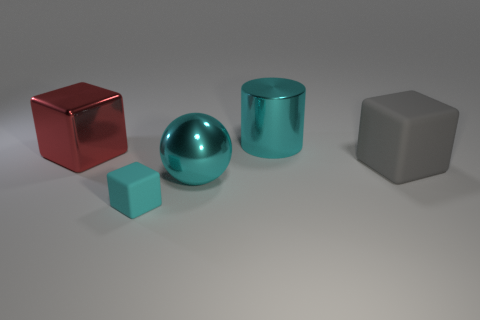There is a sphere that is the same color as the small cube; what size is it?
Provide a succinct answer. Large. There is a tiny rubber thing; does it have the same color as the big metallic object that is in front of the gray cube?
Offer a terse response. Yes. What is the color of the object that is to the right of the red thing and left of the ball?
Provide a succinct answer. Cyan. What number of other things are there of the same shape as the big matte object?
Make the answer very short. 2. Is the color of the matte object left of the cyan metallic cylinder the same as the big metallic thing in front of the large gray cube?
Offer a very short reply. Yes. There is a cyan shiny object right of the big cyan metal sphere; is it the same size as the cyan block to the right of the red object?
Keep it short and to the point. No. What material is the cyan object that is behind the cyan metal object on the left side of the large cyan object behind the red object?
Ensure brevity in your answer.  Metal. Does the tiny cyan rubber thing have the same shape as the red object?
Offer a very short reply. Yes. What is the material of the red thing that is the same shape as the big gray matte object?
Provide a succinct answer. Metal. What number of metallic cylinders are the same color as the metal ball?
Make the answer very short. 1. 